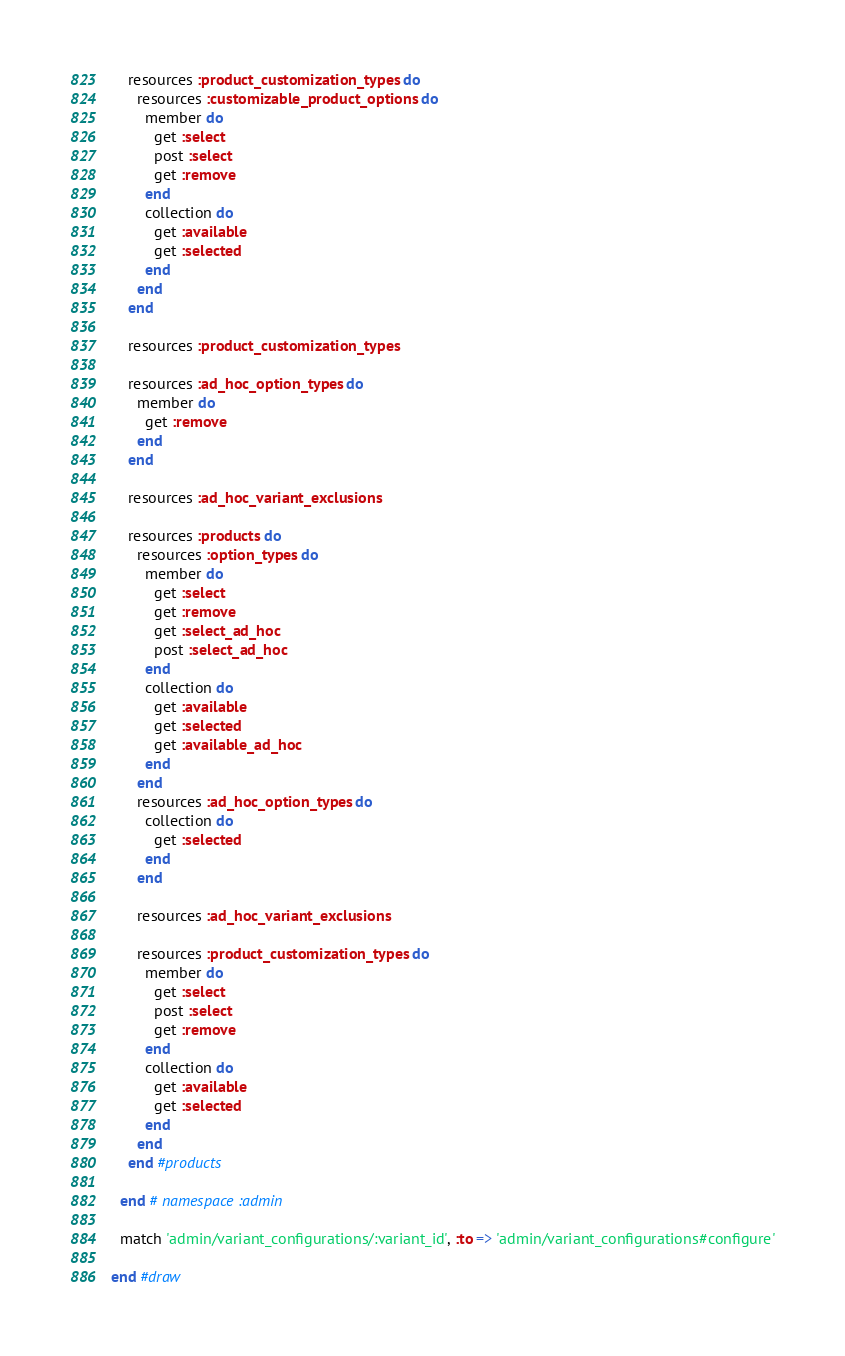Convert code to text. <code><loc_0><loc_0><loc_500><loc_500><_Ruby_>    resources :product_customization_types do
      resources :customizable_product_options do
        member do
          get :select
          post :select
          get :remove
        end
        collection do
          get :available
          get :selected
        end
      end
    end

    resources :product_customization_types

    resources :ad_hoc_option_types do
      member do
        get :remove
      end
    end

    resources :ad_hoc_variant_exclusions

    resources :products do
      resources :option_types do
        member do
          get :select
          get :remove
          get :select_ad_hoc
          post :select_ad_hoc
        end
        collection do
          get :available
          get :selected
          get :available_ad_hoc
        end
      end
      resources :ad_hoc_option_types do
        collection do
          get :selected
        end
      end

      resources :ad_hoc_variant_exclusions

      resources :product_customization_types do
        member do
          get :select
          post :select
          get :remove
        end
        collection do
          get :available
          get :selected
        end
      end
    end #products

  end # namespace :admin

  match 'admin/variant_configurations/:variant_id', :to => 'admin/variant_configurations#configure'

end #draw
</code> 